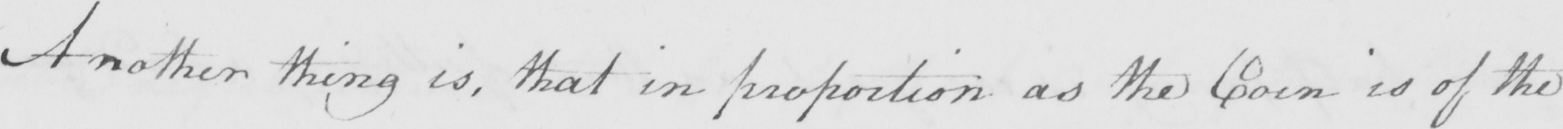Transcribe the text shown in this historical manuscript line. Another thing is , that in proportion as the Coin is of the 